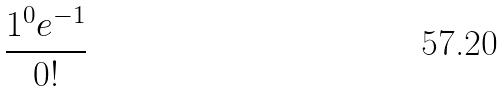<formula> <loc_0><loc_0><loc_500><loc_500>\frac { 1 ^ { 0 } e ^ { - 1 } } { 0 ! }</formula> 